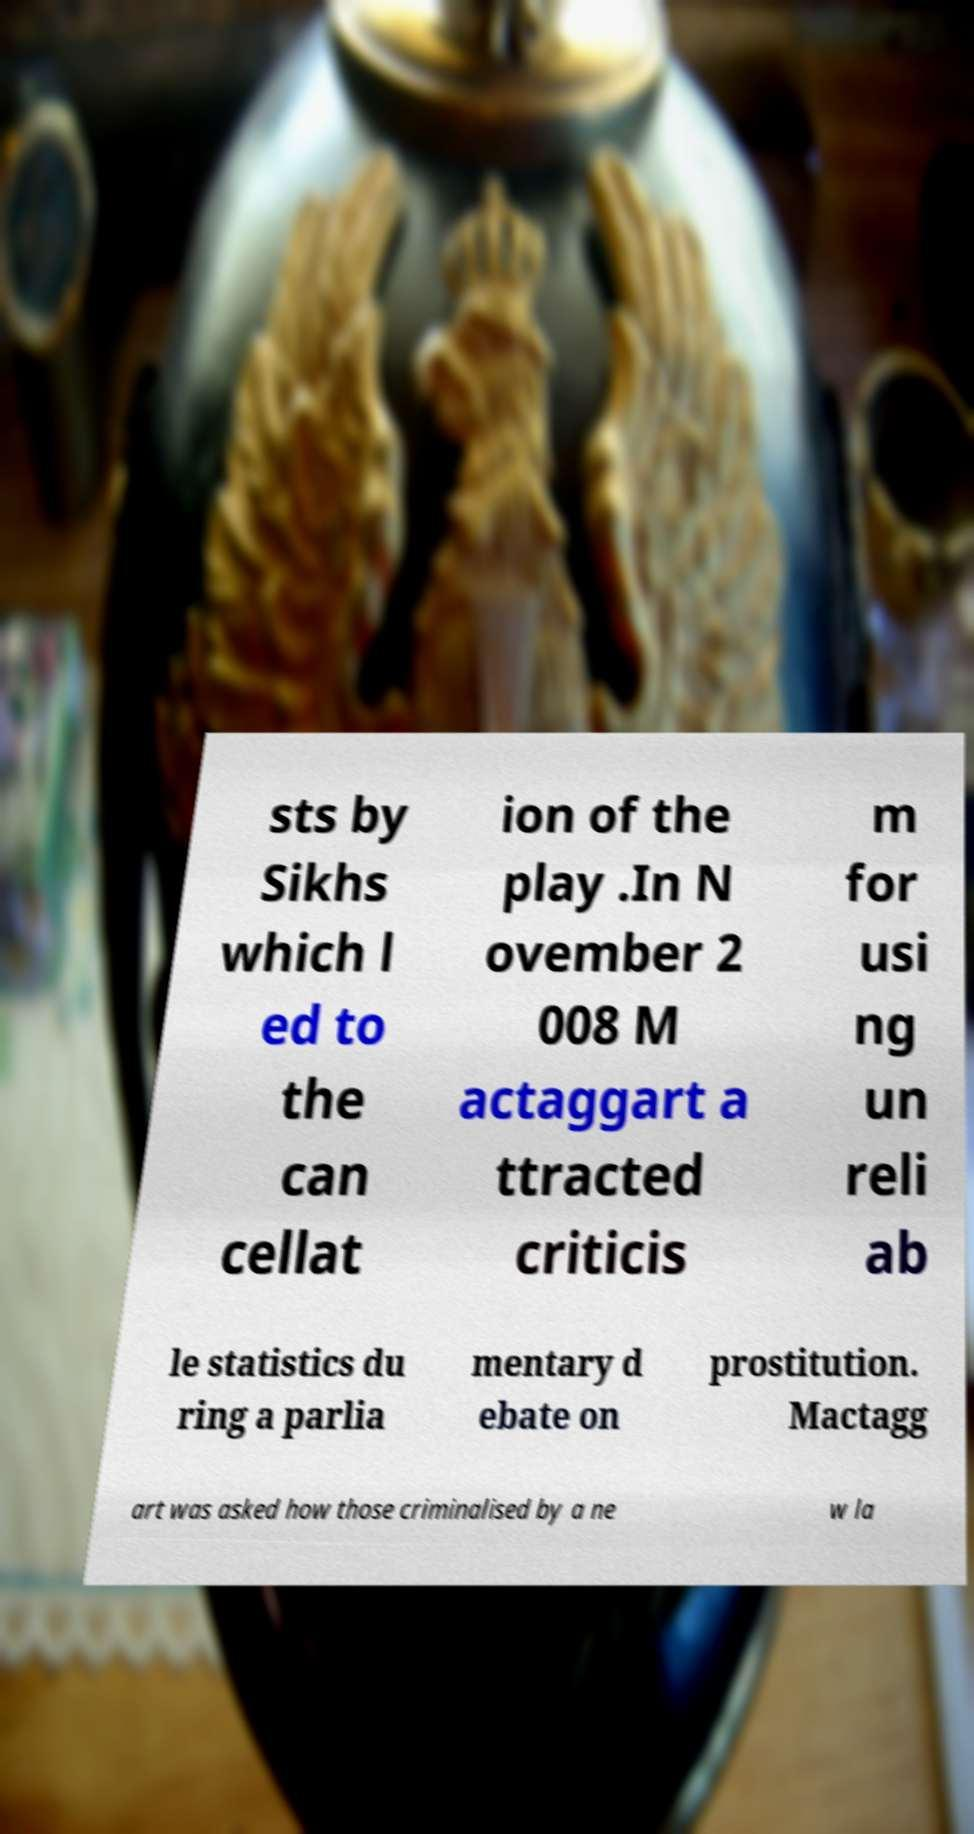There's text embedded in this image that I need extracted. Can you transcribe it verbatim? sts by Sikhs which l ed to the can cellat ion of the play .In N ovember 2 008 M actaggart a ttracted criticis m for usi ng un reli ab le statistics du ring a parlia mentary d ebate on prostitution. Mactagg art was asked how those criminalised by a ne w la 